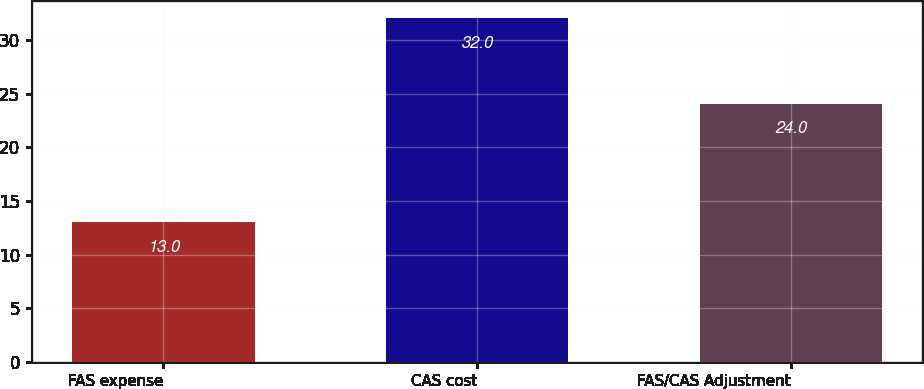<chart> <loc_0><loc_0><loc_500><loc_500><bar_chart><fcel>FAS expense<fcel>CAS cost<fcel>FAS/CAS Adjustment<nl><fcel>13<fcel>32<fcel>24<nl></chart> 